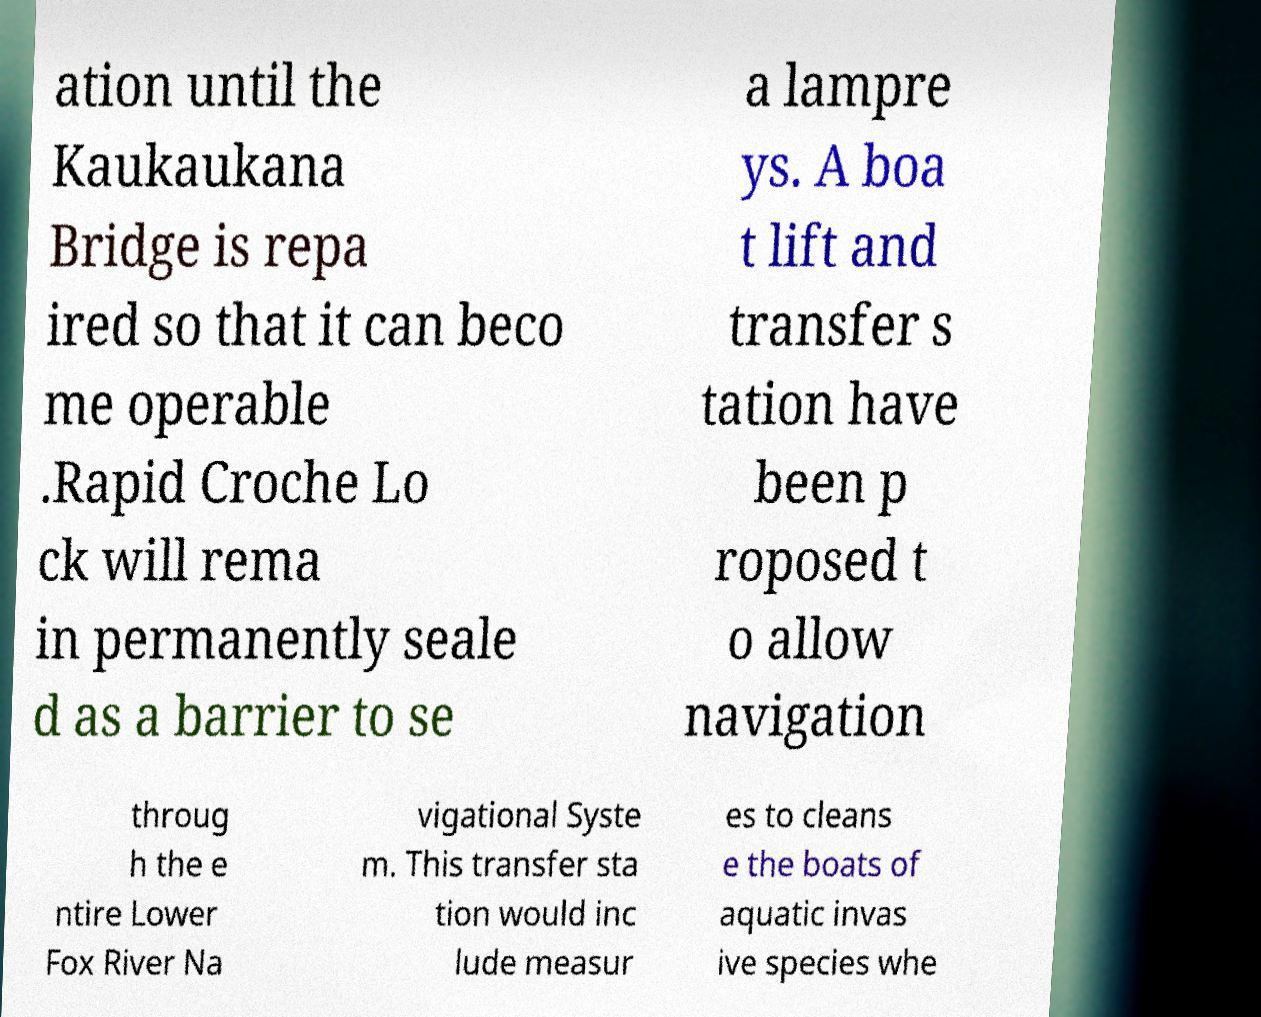What messages or text are displayed in this image? I need them in a readable, typed format. ation until the Kaukaukana Bridge is repa ired so that it can beco me operable .Rapid Croche Lo ck will rema in permanently seale d as a barrier to se a lampre ys. A boa t lift and transfer s tation have been p roposed t o allow navigation throug h the e ntire Lower Fox River Na vigational Syste m. This transfer sta tion would inc lude measur es to cleans e the boats of aquatic invas ive species whe 